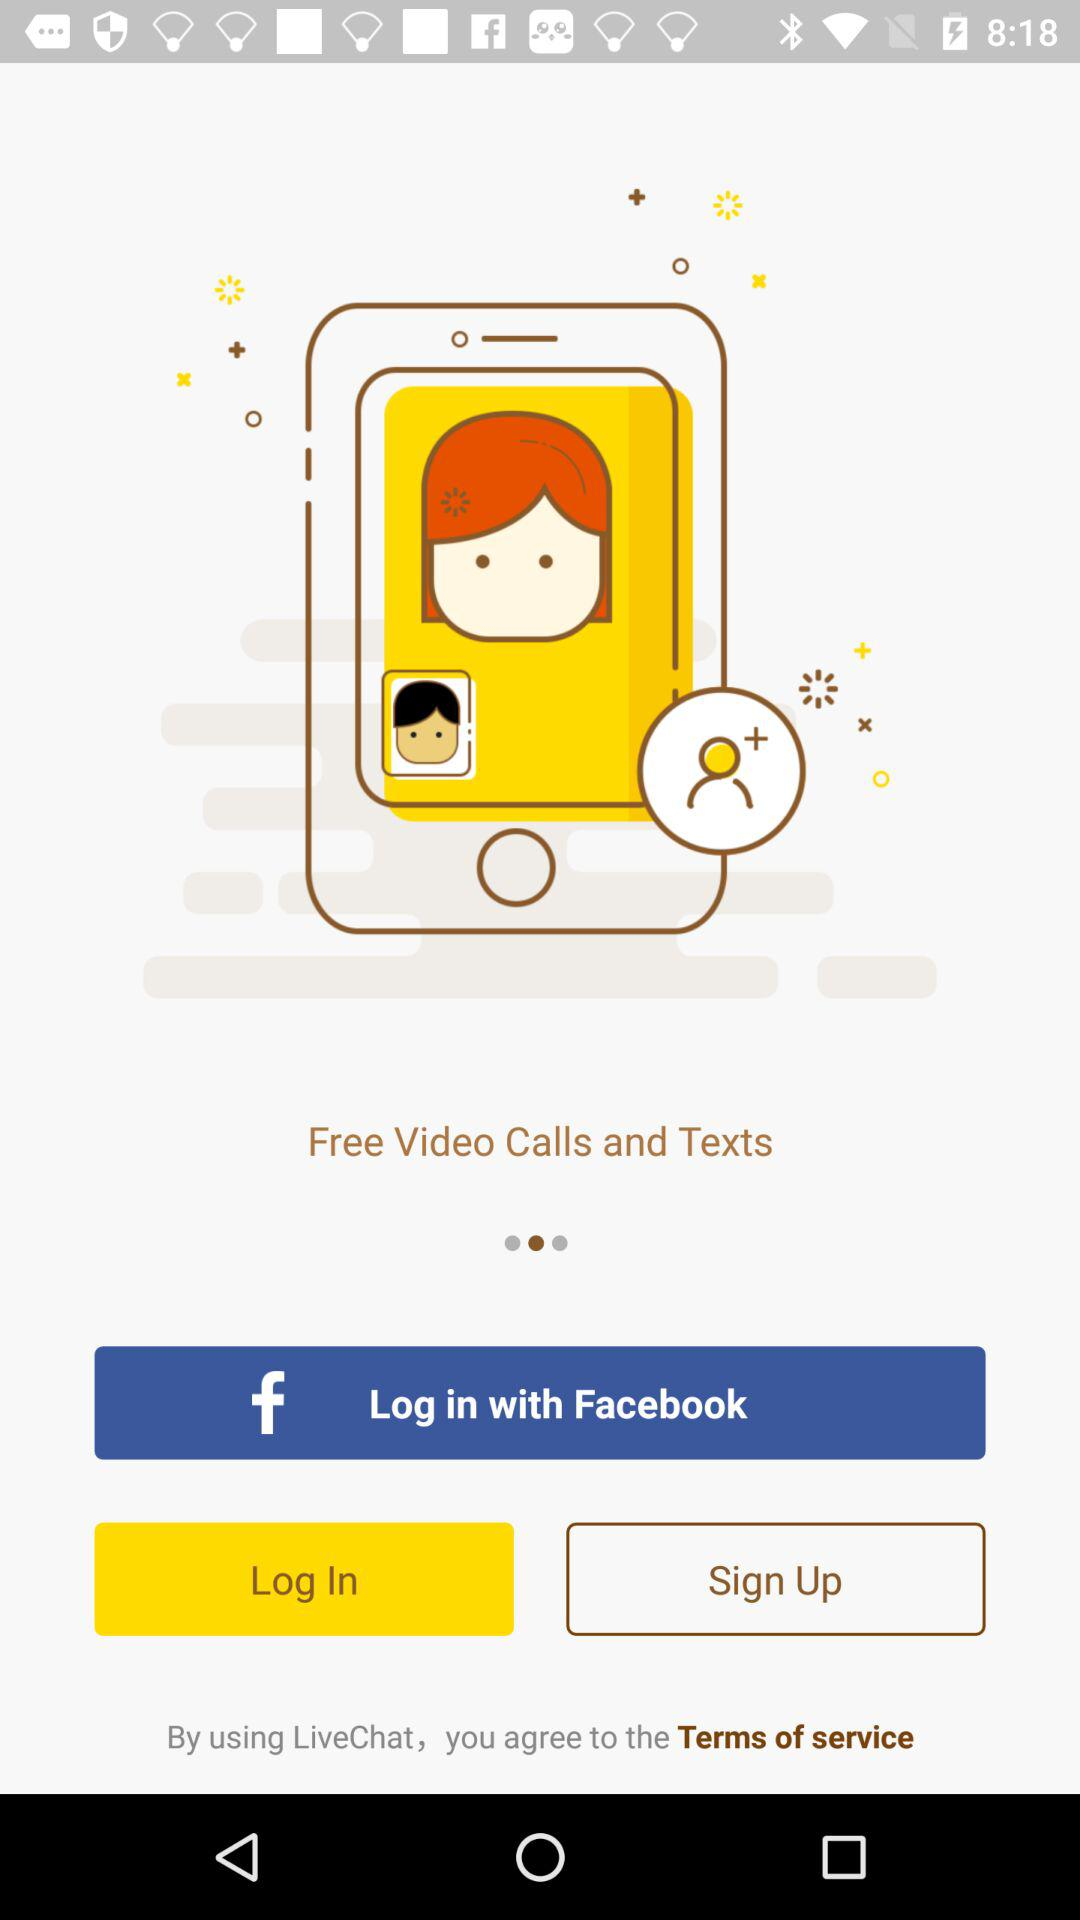What applications can we use for logging in? The application is "Facebook". 